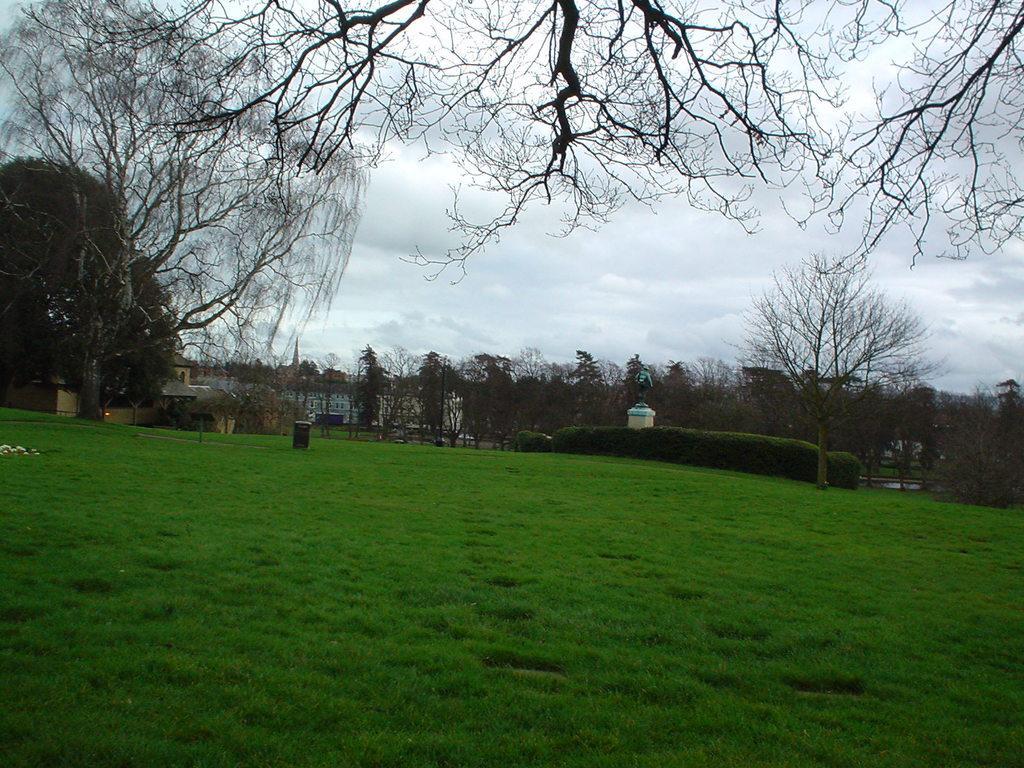Describe this image in one or two sentences. This is an outside view. At the bottom of this image I can see the grass in green color. In the background there are some trees and a building. On the top of the image I can see the sky. 